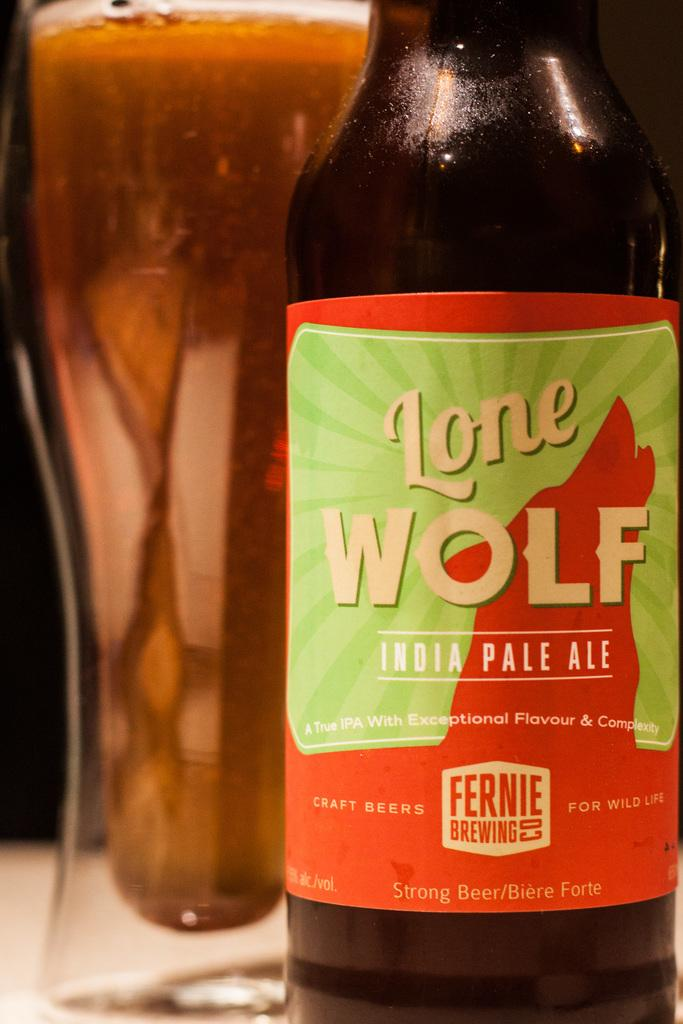<image>
Present a compact description of the photo's key features. a lone wolf beer that is next to a glass 